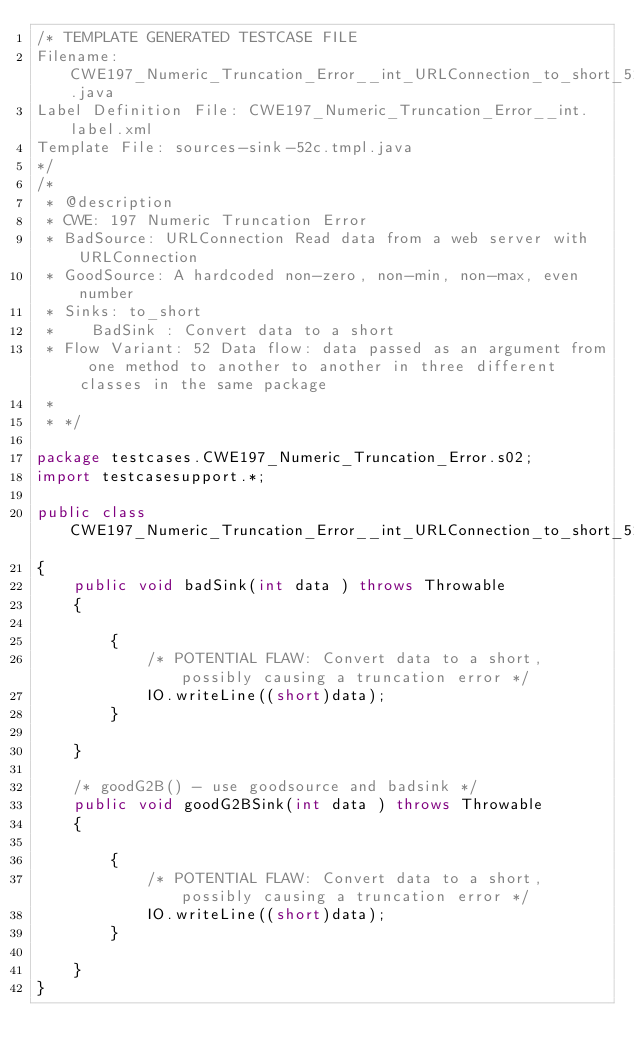<code> <loc_0><loc_0><loc_500><loc_500><_Java_>/* TEMPLATE GENERATED TESTCASE FILE
Filename: CWE197_Numeric_Truncation_Error__int_URLConnection_to_short_52c.java
Label Definition File: CWE197_Numeric_Truncation_Error__int.label.xml
Template File: sources-sink-52c.tmpl.java
*/
/*
 * @description
 * CWE: 197 Numeric Truncation Error
 * BadSource: URLConnection Read data from a web server with URLConnection
 * GoodSource: A hardcoded non-zero, non-min, non-max, even number
 * Sinks: to_short
 *    BadSink : Convert data to a short
 * Flow Variant: 52 Data flow: data passed as an argument from one method to another to another in three different classes in the same package
 *
 * */

package testcases.CWE197_Numeric_Truncation_Error.s02;
import testcasesupport.*;

public class CWE197_Numeric_Truncation_Error__int_URLConnection_to_short_52c
{
    public void badSink(int data ) throws Throwable
    {

        {
            /* POTENTIAL FLAW: Convert data to a short, possibly causing a truncation error */
            IO.writeLine((short)data);
        }

    }

    /* goodG2B() - use goodsource and badsink */
    public void goodG2BSink(int data ) throws Throwable
    {

        {
            /* POTENTIAL FLAW: Convert data to a short, possibly causing a truncation error */
            IO.writeLine((short)data);
        }

    }
}
</code> 